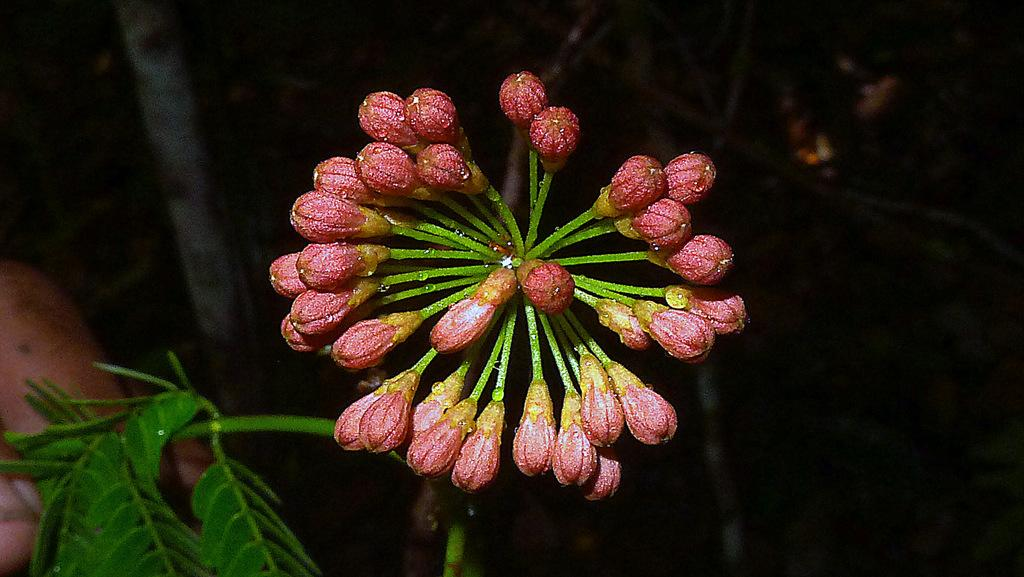What is the main subject of the image? There is a flower in the image. Where is the flower located? The flower is on a plant. What colors can be seen on the flower? The flower has pink and green colors. What is the color of the background in the image? The background of the image is black. How many quarters are stacked on top of the crate in the image? There is no crate or quarters present in the image. 